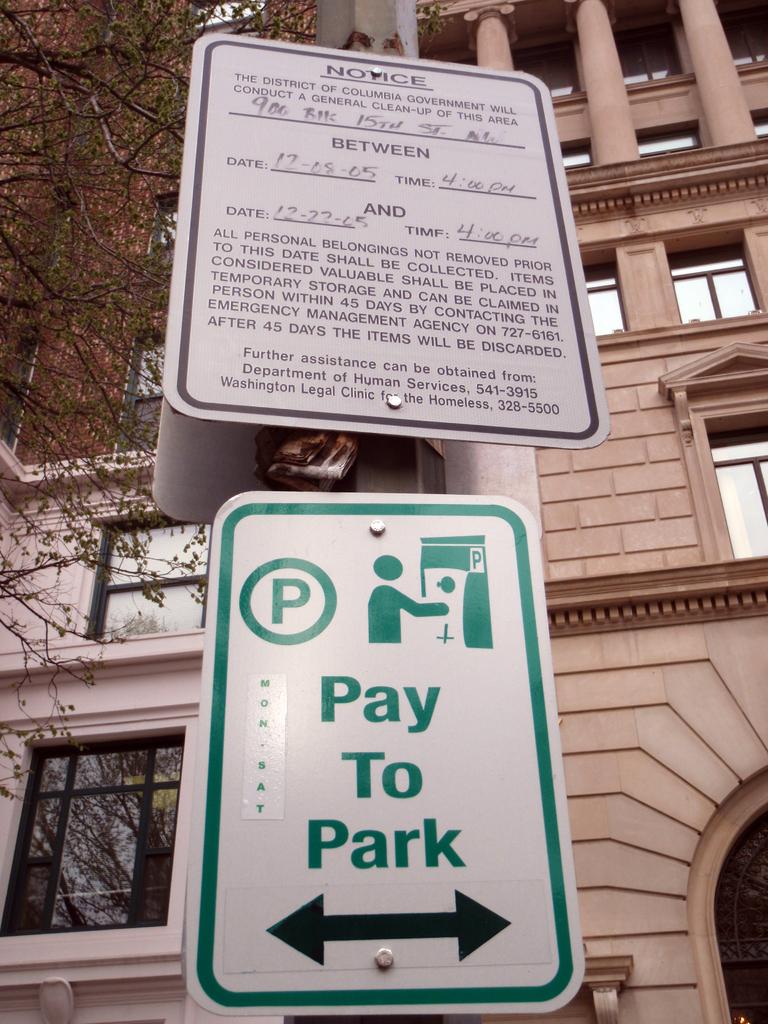What does the sign say?
Provide a short and direct response. Pay to park. What time is written on the notice?
Provide a succinct answer. 4:00 pm. 